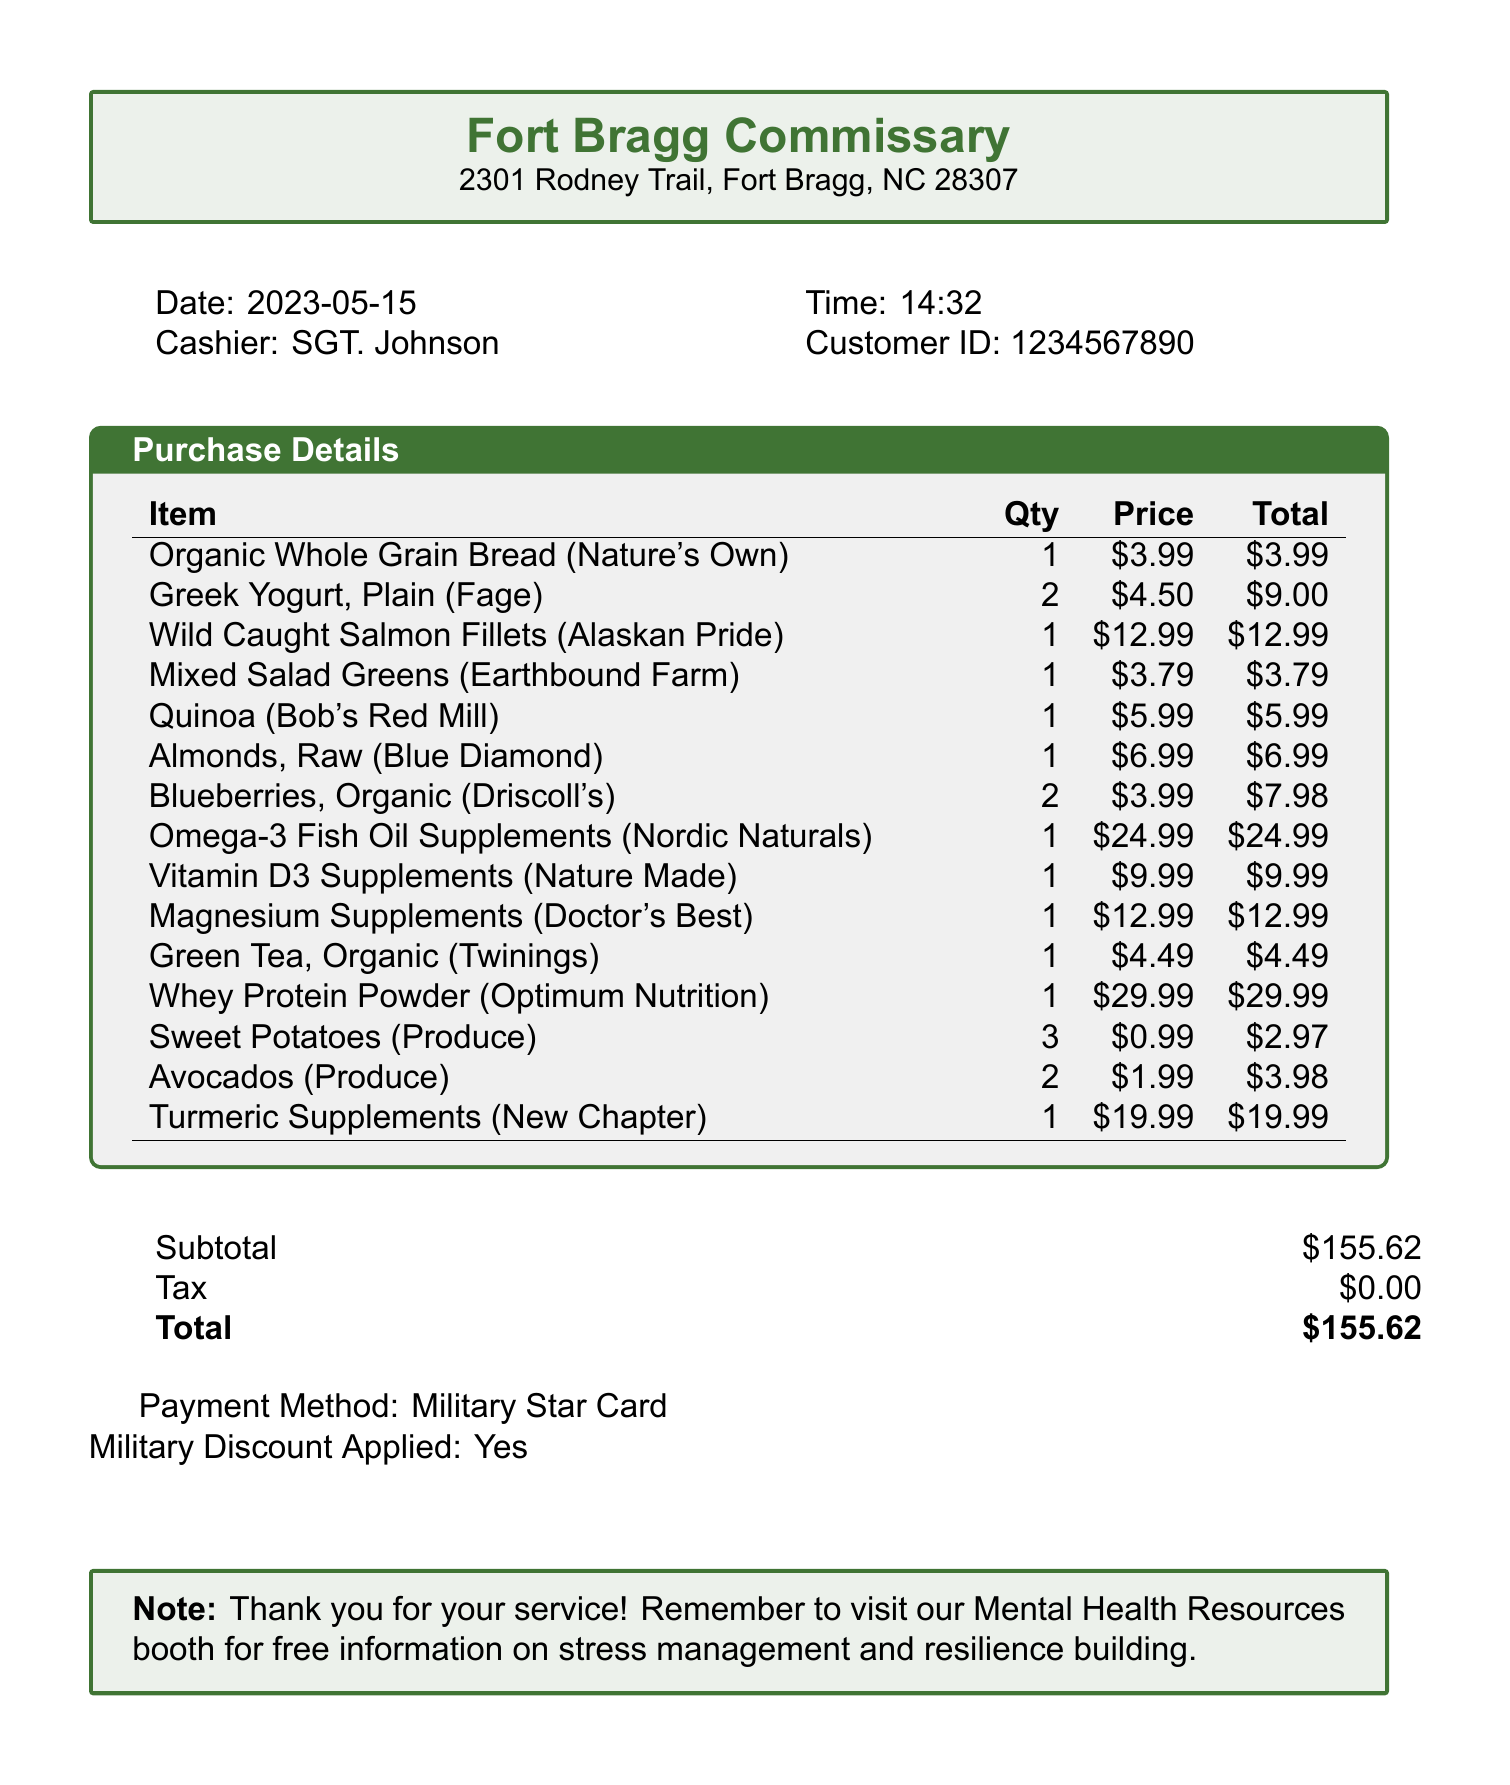What is the store name? The store name appears at the top of the document, stating "Fort Bragg Commissary."
Answer: Fort Bragg Commissary What date was the purchase made? The date of the purchase is listed under the purchase details section.
Answer: 2023-05-15 Who was the cashier? The cashier's name is noted in the transaction details on the receipt.
Answer: SGT. Johnson What is the total amount spent? The total amount is summarized at the bottom of the receipt.
Answer: $155.62 What item had the highest price? The item prices are listed alongside the items, allowing identification of the highest price.
Answer: Whey Protein Powder How many quantities of Greek Yogurt were purchased? The quantity is specified next to the item name within the purchase details section.
Answer: 2 What is indicated about military discounts? The receipt includes a note about whether a military discount was applied.
Answer: Yes Which supplement was priced at $24.99? The price list allows for identification of items by their price.
Answer: Omega-3 Fish Oil Supplements How many different types of supplements were bought? The count of supplement items can be tallied from the list provided.
Answer: 4 